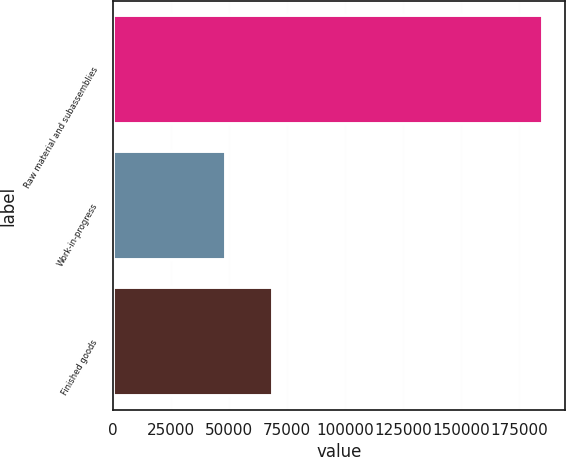<chart> <loc_0><loc_0><loc_500><loc_500><bar_chart><fcel>Raw material and subassemblies<fcel>Work-in-progress<fcel>Finished goods<nl><fcel>185359<fcel>48788<fcel>69009<nl></chart> 